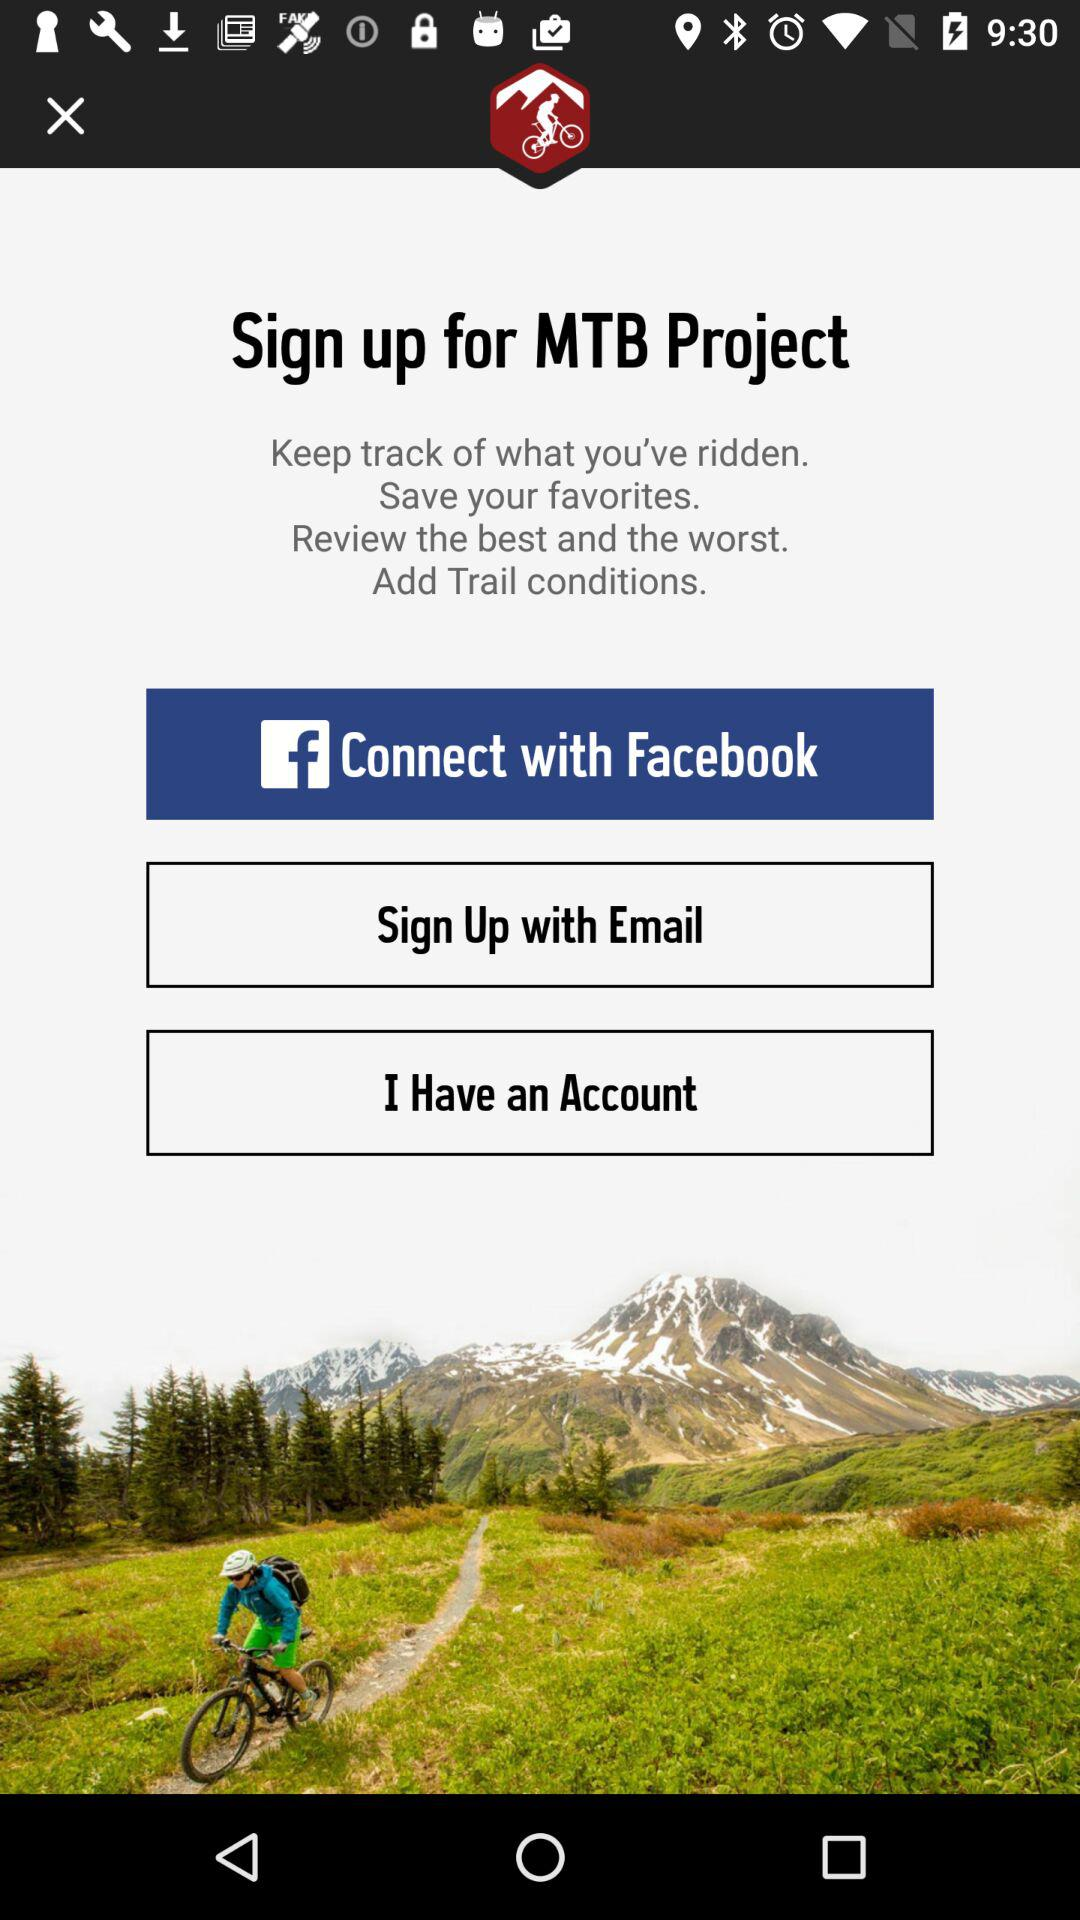What application is used for login? The application used for login is "Facebook". 